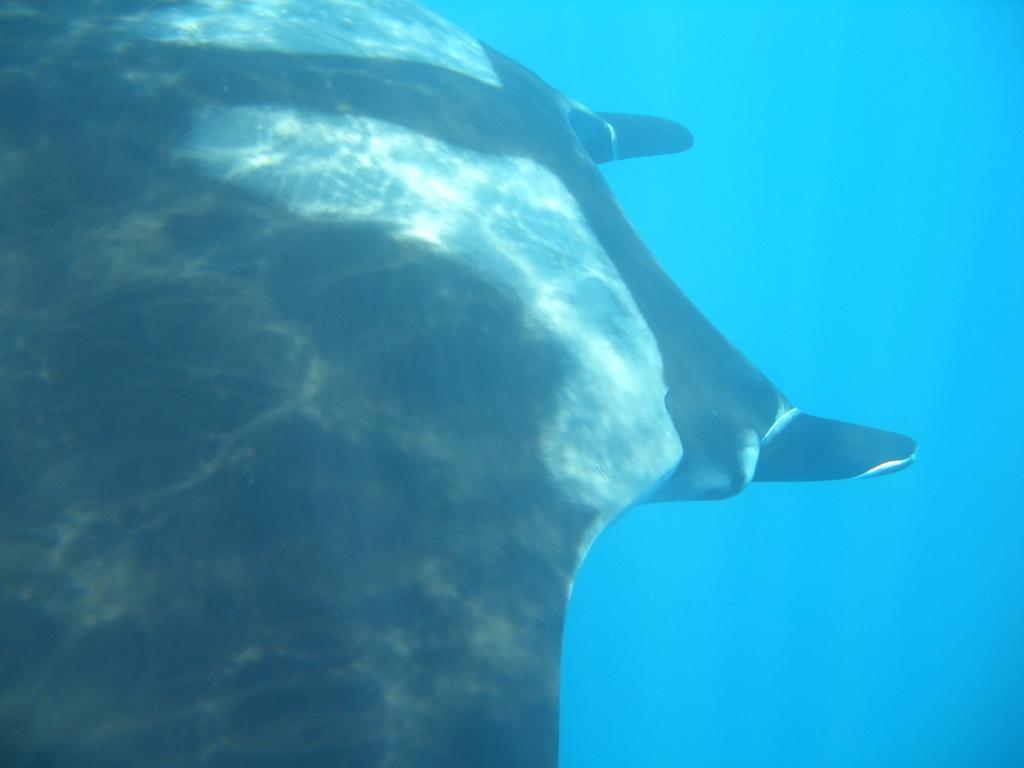In one or two sentences, can you explain what this image depicts? In this image I can see the picture of an aquatic animal which is black in color. In the background I can see the water. 